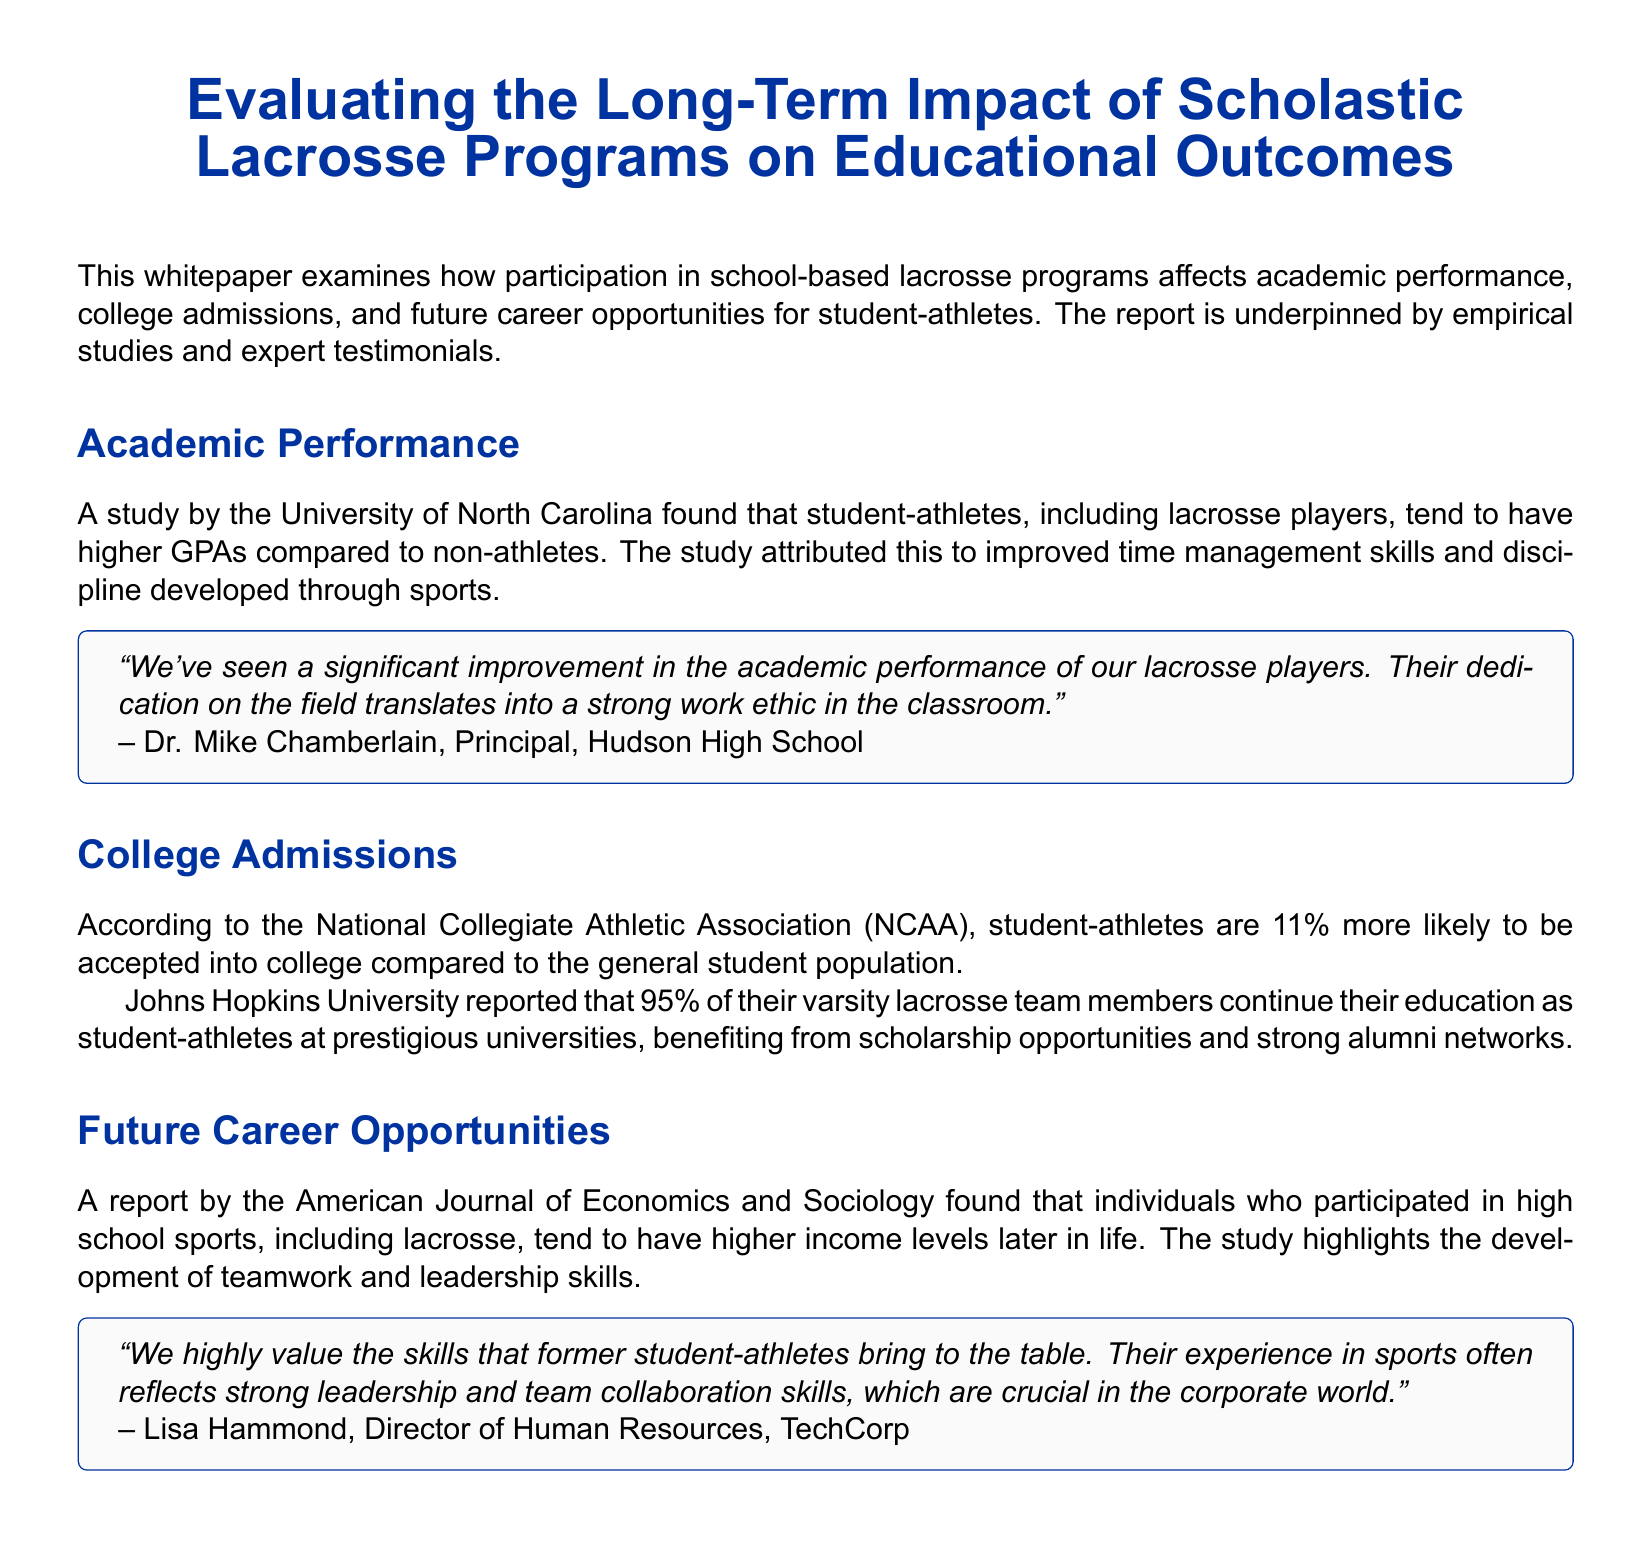What is the title of the whitepaper? The title of the whitepaper is stated prominently at the beginning of the document.
Answer: Evaluating the Long-Term Impact of Scholastic Lacrosse Programs on Educational Outcomes Which university conducted a study on student-athletes' GPAs? The document mentions a specific university that found higher GPAs among student-athletes, including lacrosse players.
Answer: University of North Carolina What percentage more likely are student-athletes to be accepted into college? The statistics related to college admissions highlight a significant percentage difference provided in the report.
Answer: 11% What is the reported percentage of Johns Hopkins University lacrosse players who continue their education? The document specifies the continuation rate of varsity lacrosse team members at Johns Hopkins University.
Answer: 95% What did the American Journal of Economics and Sociology report about former high school sports participants? The report discusses the benefits of participation in high school sports, including specific outcomes regarding income.
Answer: Higher income levels Who is cited as stating that lacrosse players show a strong work ethic? The document attributes a quote regarding academic performance and work ethic to a specific individual.
Answer: Dr. Mike Chamberlain What skills do former student-athletes reportedly bring to the corporate world? The document outlines key skills acquired through sports participation that are valued in the workplace.
Answer: Leadership and team collaboration skills What factors contributed to higher GPAs in student-athletes according to the University of North Carolina study? The study describes specific traits developed through sports that influence academic success.
Answer: Time management skills and discipline 